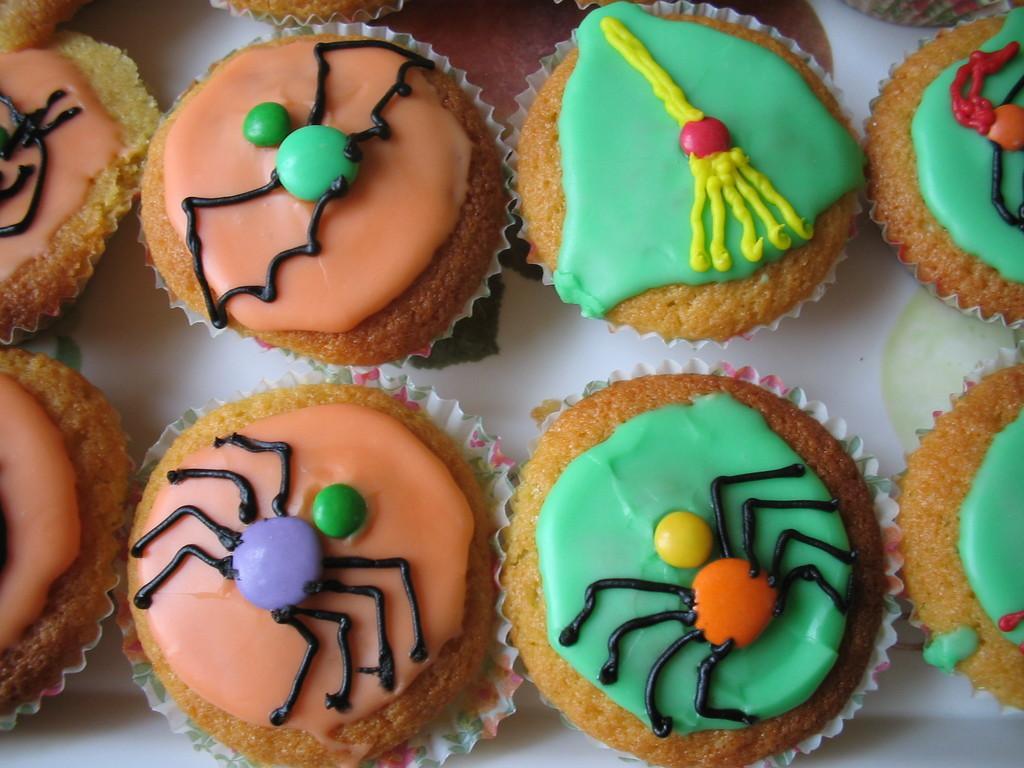Can you describe this image briefly? In this image, we can see desserts on the table. 